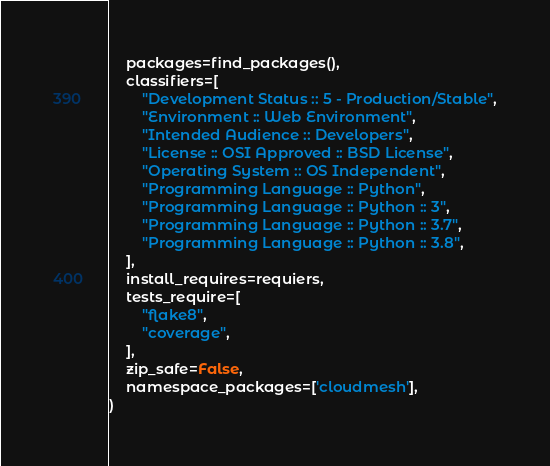Convert code to text. <code><loc_0><loc_0><loc_500><loc_500><_Python_>    packages=find_packages(),
    classifiers=[
        "Development Status :: 5 - Production/Stable",
        "Environment :: Web Environment",
        "Intended Audience :: Developers",
        "License :: OSI Approved :: BSD License",
        "Operating System :: OS Independent",
        "Programming Language :: Python",
        "Programming Language :: Python :: 3",
        "Programming Language :: Python :: 3.7",
        "Programming Language :: Python :: 3.8",
    ],
    install_requires=requiers,
    tests_require=[
        "flake8",
        "coverage",
    ],
    zip_safe=False,
    namespace_packages=['cloudmesh'],
)
</code> 